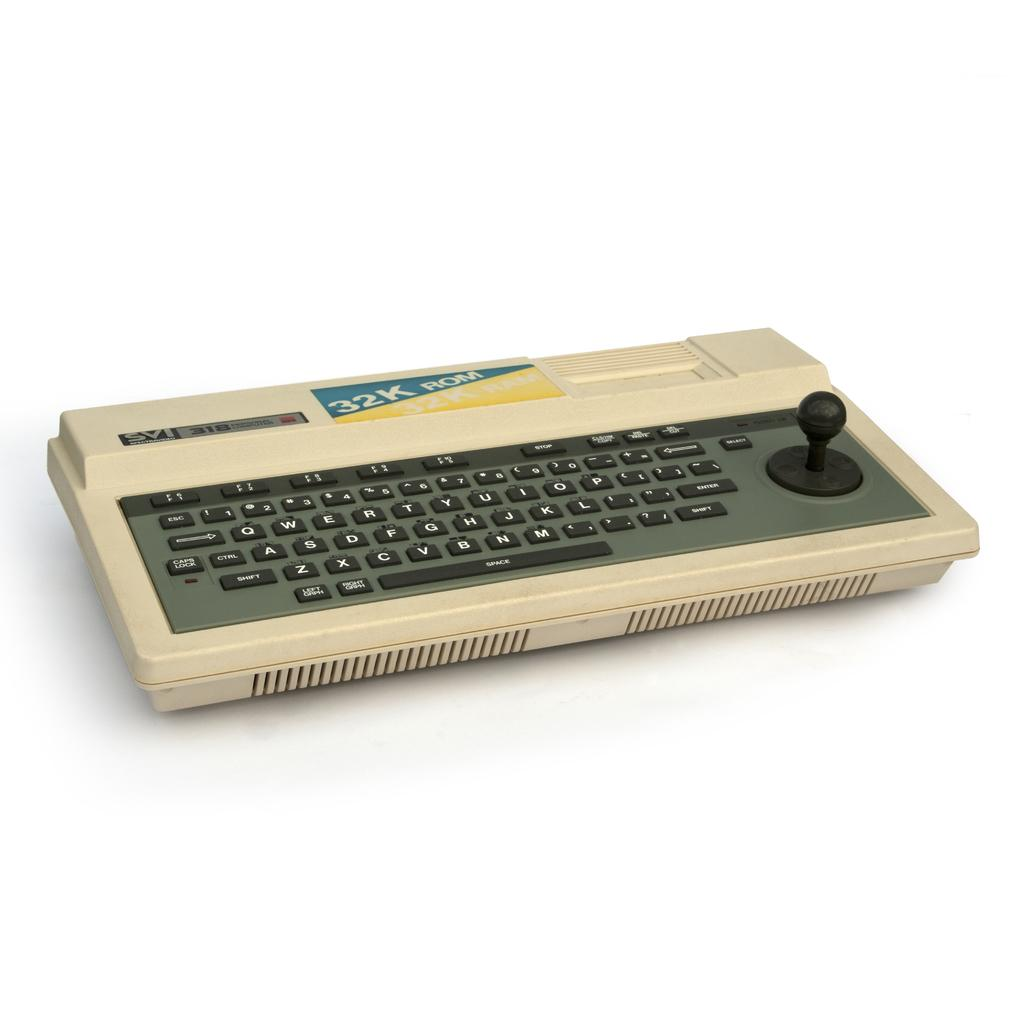<image>
Summarize the visual content of the image. A keyboard that says SI 318 with a built in joystick. 